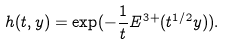Convert formula to latex. <formula><loc_0><loc_0><loc_500><loc_500>h ( t , y ) = \exp ( - \frac { 1 } { t } E ^ { 3 + } ( t ^ { 1 / 2 } y ) ) .</formula> 